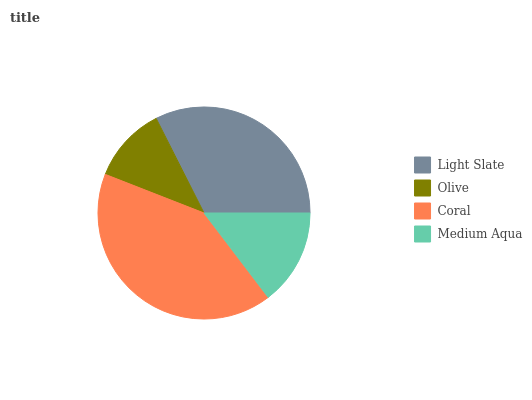Is Olive the minimum?
Answer yes or no. Yes. Is Coral the maximum?
Answer yes or no. Yes. Is Coral the minimum?
Answer yes or no. No. Is Olive the maximum?
Answer yes or no. No. Is Coral greater than Olive?
Answer yes or no. Yes. Is Olive less than Coral?
Answer yes or no. Yes. Is Olive greater than Coral?
Answer yes or no. No. Is Coral less than Olive?
Answer yes or no. No. Is Light Slate the high median?
Answer yes or no. Yes. Is Medium Aqua the low median?
Answer yes or no. Yes. Is Medium Aqua the high median?
Answer yes or no. No. Is Light Slate the low median?
Answer yes or no. No. 